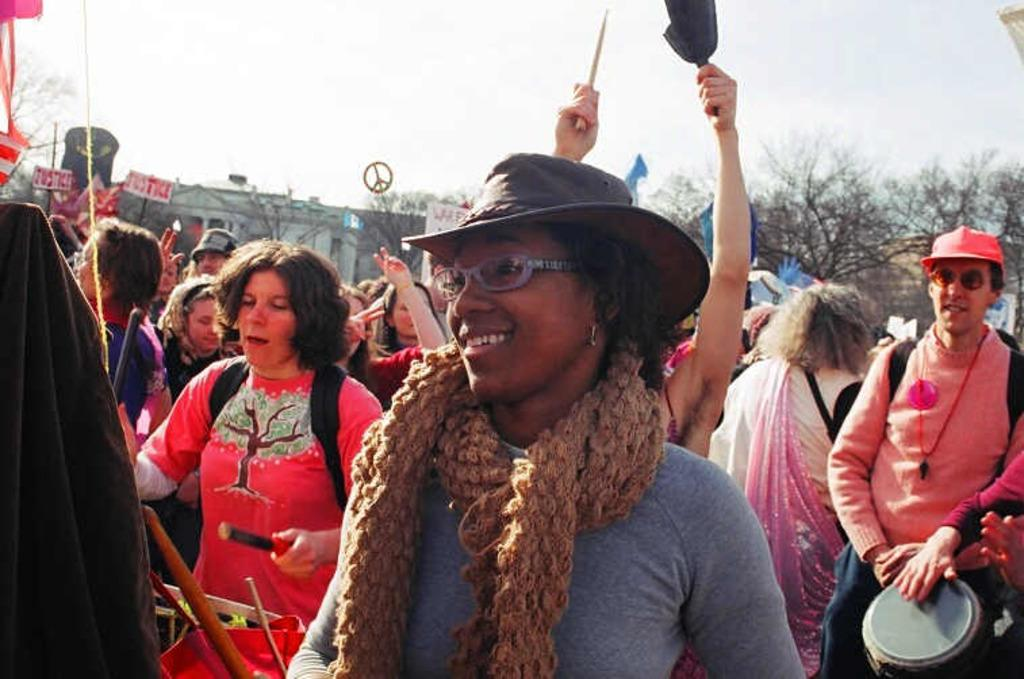How many people are present in the image? There are people in the image, but the exact number is not specified. What is the person holding in their hands? There is a person holding something in their hands, but the specific object is not mentioned. What can be seen in the background of the image? There are buildings, trees, and the sky visible in the background of the image. How many geese are flying over the station in the image? There is no mention of geese or a station in the image, so we cannot answer this question. 